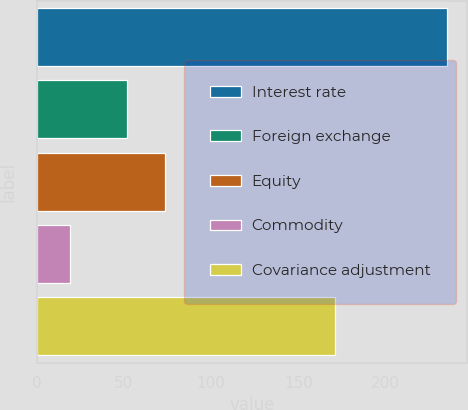Convert chart to OTSL. <chart><loc_0><loc_0><loc_500><loc_500><bar_chart><fcel>Interest rate<fcel>Foreign exchange<fcel>Equity<fcel>Commodity<fcel>Covariance adjustment<nl><fcel>235<fcel>52<fcel>73.6<fcel>19<fcel>171<nl></chart> 